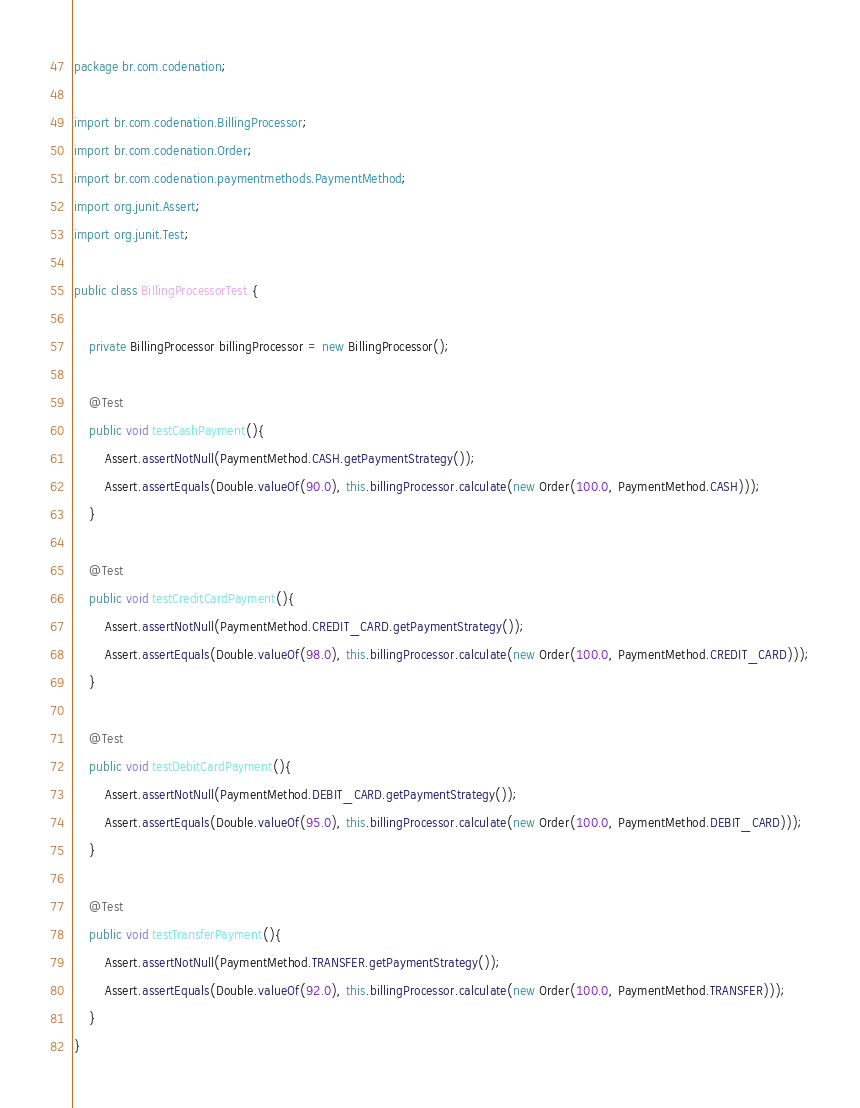<code> <loc_0><loc_0><loc_500><loc_500><_Java_>package br.com.codenation;

import br.com.codenation.BillingProcessor;
import br.com.codenation.Order;
import br.com.codenation.paymentmethods.PaymentMethod;
import org.junit.Assert;
import org.junit.Test;

public class BillingProcessorTest {

    private BillingProcessor billingProcessor = new BillingProcessor();

    @Test
    public void testCashPayment(){
        Assert.assertNotNull(PaymentMethod.CASH.getPaymentStrategy());
        Assert.assertEquals(Double.valueOf(90.0), this.billingProcessor.calculate(new Order(100.0, PaymentMethod.CASH)));
    }

    @Test
    public void testCreditCardPayment(){
        Assert.assertNotNull(PaymentMethod.CREDIT_CARD.getPaymentStrategy());
        Assert.assertEquals(Double.valueOf(98.0), this.billingProcessor.calculate(new Order(100.0, PaymentMethod.CREDIT_CARD)));
    }

    @Test
    public void testDebitCardPayment(){
        Assert.assertNotNull(PaymentMethod.DEBIT_CARD.getPaymentStrategy());
        Assert.assertEquals(Double.valueOf(95.0), this.billingProcessor.calculate(new Order(100.0, PaymentMethod.DEBIT_CARD)));
    }

    @Test
    public void testTransferPayment(){
        Assert.assertNotNull(PaymentMethod.TRANSFER.getPaymentStrategy());
        Assert.assertEquals(Double.valueOf(92.0), this.billingProcessor.calculate(new Order(100.0, PaymentMethod.TRANSFER)));
    }
}
</code> 